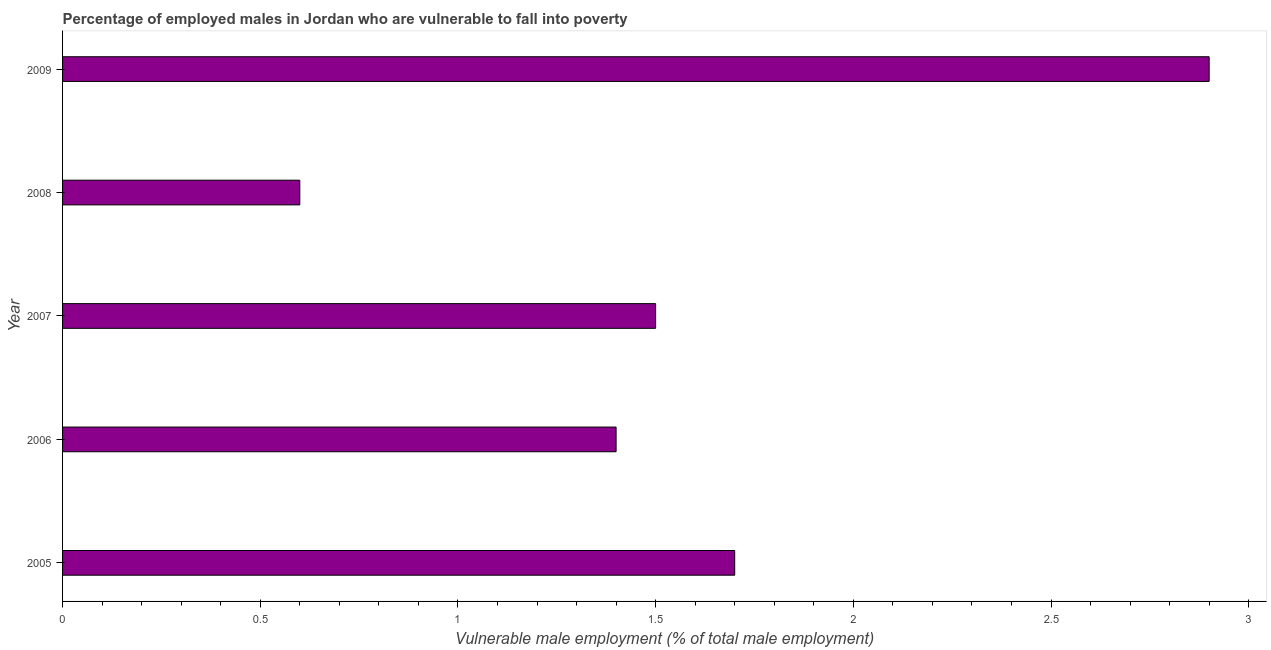Does the graph contain any zero values?
Ensure brevity in your answer.  No. Does the graph contain grids?
Ensure brevity in your answer.  No. What is the title of the graph?
Keep it short and to the point. Percentage of employed males in Jordan who are vulnerable to fall into poverty. What is the label or title of the X-axis?
Offer a very short reply. Vulnerable male employment (% of total male employment). What is the percentage of employed males who are vulnerable to fall into poverty in 2005?
Offer a terse response. 1.7. Across all years, what is the maximum percentage of employed males who are vulnerable to fall into poverty?
Offer a very short reply. 2.9. Across all years, what is the minimum percentage of employed males who are vulnerable to fall into poverty?
Keep it short and to the point. 0.6. What is the sum of the percentage of employed males who are vulnerable to fall into poverty?
Ensure brevity in your answer.  8.1. What is the average percentage of employed males who are vulnerable to fall into poverty per year?
Your answer should be compact. 1.62. What is the median percentage of employed males who are vulnerable to fall into poverty?
Provide a short and direct response. 1.5. In how many years, is the percentage of employed males who are vulnerable to fall into poverty greater than 0.3 %?
Offer a very short reply. 5. What is the ratio of the percentage of employed males who are vulnerable to fall into poverty in 2007 to that in 2009?
Your answer should be compact. 0.52. Is the sum of the percentage of employed males who are vulnerable to fall into poverty in 2006 and 2009 greater than the maximum percentage of employed males who are vulnerable to fall into poverty across all years?
Provide a succinct answer. Yes. What is the difference between the highest and the lowest percentage of employed males who are vulnerable to fall into poverty?
Make the answer very short. 2.3. In how many years, is the percentage of employed males who are vulnerable to fall into poverty greater than the average percentage of employed males who are vulnerable to fall into poverty taken over all years?
Provide a short and direct response. 2. How many years are there in the graph?
Your answer should be compact. 5. What is the difference between two consecutive major ticks on the X-axis?
Your answer should be compact. 0.5. Are the values on the major ticks of X-axis written in scientific E-notation?
Your response must be concise. No. What is the Vulnerable male employment (% of total male employment) in 2005?
Make the answer very short. 1.7. What is the Vulnerable male employment (% of total male employment) in 2006?
Make the answer very short. 1.4. What is the Vulnerable male employment (% of total male employment) in 2008?
Provide a succinct answer. 0.6. What is the Vulnerable male employment (% of total male employment) of 2009?
Ensure brevity in your answer.  2.9. What is the difference between the Vulnerable male employment (% of total male employment) in 2005 and 2007?
Offer a very short reply. 0.2. What is the difference between the Vulnerable male employment (% of total male employment) in 2005 and 2009?
Your response must be concise. -1.2. What is the difference between the Vulnerable male employment (% of total male employment) in 2006 and 2007?
Offer a terse response. -0.1. What is the difference between the Vulnerable male employment (% of total male employment) in 2006 and 2008?
Provide a short and direct response. 0.8. What is the difference between the Vulnerable male employment (% of total male employment) in 2008 and 2009?
Offer a very short reply. -2.3. What is the ratio of the Vulnerable male employment (% of total male employment) in 2005 to that in 2006?
Your answer should be very brief. 1.21. What is the ratio of the Vulnerable male employment (% of total male employment) in 2005 to that in 2007?
Your response must be concise. 1.13. What is the ratio of the Vulnerable male employment (% of total male employment) in 2005 to that in 2008?
Offer a very short reply. 2.83. What is the ratio of the Vulnerable male employment (% of total male employment) in 2005 to that in 2009?
Provide a succinct answer. 0.59. What is the ratio of the Vulnerable male employment (% of total male employment) in 2006 to that in 2007?
Offer a terse response. 0.93. What is the ratio of the Vulnerable male employment (% of total male employment) in 2006 to that in 2008?
Your answer should be compact. 2.33. What is the ratio of the Vulnerable male employment (% of total male employment) in 2006 to that in 2009?
Provide a short and direct response. 0.48. What is the ratio of the Vulnerable male employment (% of total male employment) in 2007 to that in 2009?
Give a very brief answer. 0.52. What is the ratio of the Vulnerable male employment (% of total male employment) in 2008 to that in 2009?
Keep it short and to the point. 0.21. 